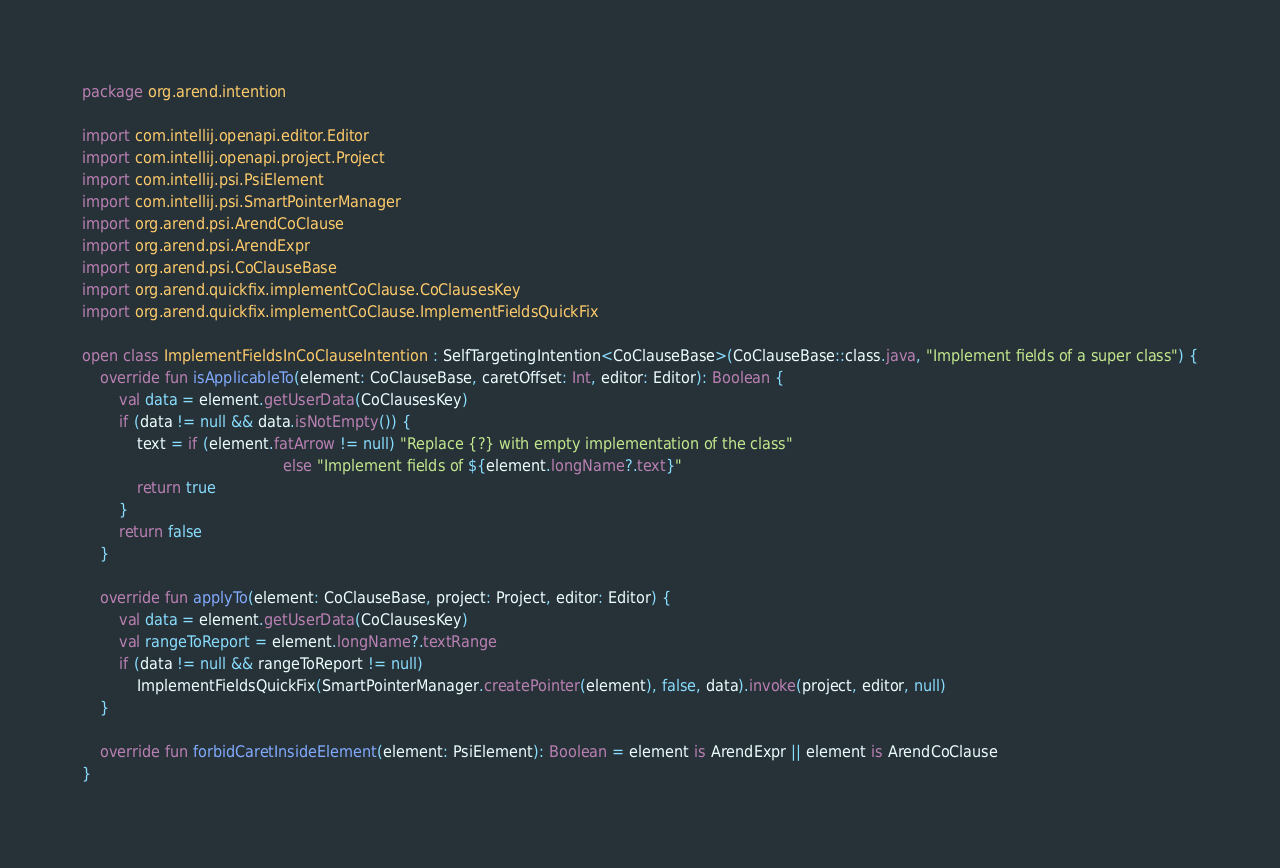Convert code to text. <code><loc_0><loc_0><loc_500><loc_500><_Kotlin_>package org.arend.intention

import com.intellij.openapi.editor.Editor
import com.intellij.openapi.project.Project
import com.intellij.psi.PsiElement
import com.intellij.psi.SmartPointerManager
import org.arend.psi.ArendCoClause
import org.arend.psi.ArendExpr
import org.arend.psi.CoClauseBase
import org.arend.quickfix.implementCoClause.CoClausesKey
import org.arend.quickfix.implementCoClause.ImplementFieldsQuickFix

open class ImplementFieldsInCoClauseIntention : SelfTargetingIntention<CoClauseBase>(CoClauseBase::class.java, "Implement fields of a super class") {
    override fun isApplicableTo(element: CoClauseBase, caretOffset: Int, editor: Editor): Boolean {
        val data = element.getUserData(CoClausesKey)
        if (data != null && data.isNotEmpty()) {
            text = if (element.fatArrow != null) "Replace {?} with empty implementation of the class"
                                            else "Implement fields of ${element.longName?.text}"
            return true
        }
        return false
    }

    override fun applyTo(element: CoClauseBase, project: Project, editor: Editor) {
        val data = element.getUserData(CoClausesKey)
        val rangeToReport = element.longName?.textRange
        if (data != null && rangeToReport != null)
            ImplementFieldsQuickFix(SmartPointerManager.createPointer(element), false, data).invoke(project, editor, null)
    }

    override fun forbidCaretInsideElement(element: PsiElement): Boolean = element is ArendExpr || element is ArendCoClause
}</code> 